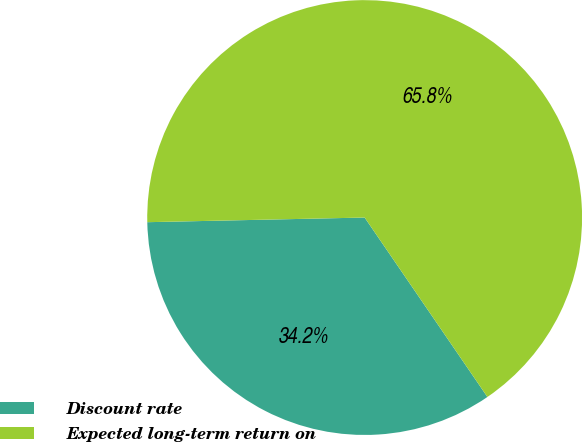Convert chart to OTSL. <chart><loc_0><loc_0><loc_500><loc_500><pie_chart><fcel>Discount rate<fcel>Expected long-term return on<nl><fcel>34.21%<fcel>65.79%<nl></chart> 